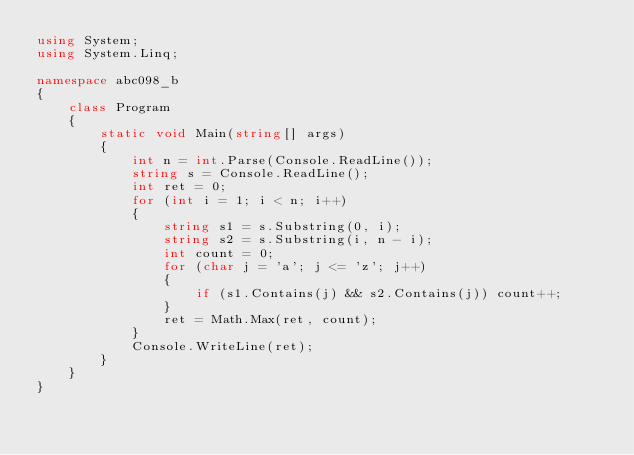Convert code to text. <code><loc_0><loc_0><loc_500><loc_500><_C#_>using System;
using System.Linq;

namespace abc098_b
{
    class Program
    {
        static void Main(string[] args)
        {
            int n = int.Parse(Console.ReadLine());
            string s = Console.ReadLine();
            int ret = 0;
            for (int i = 1; i < n; i++)
            {
                string s1 = s.Substring(0, i);
                string s2 = s.Substring(i, n - i);
                int count = 0;
                for (char j = 'a'; j <= 'z'; j++)
                {
                    if (s1.Contains(j) && s2.Contains(j)) count++;
                }
                ret = Math.Max(ret, count);
            }
            Console.WriteLine(ret);
        }
    }
}</code> 